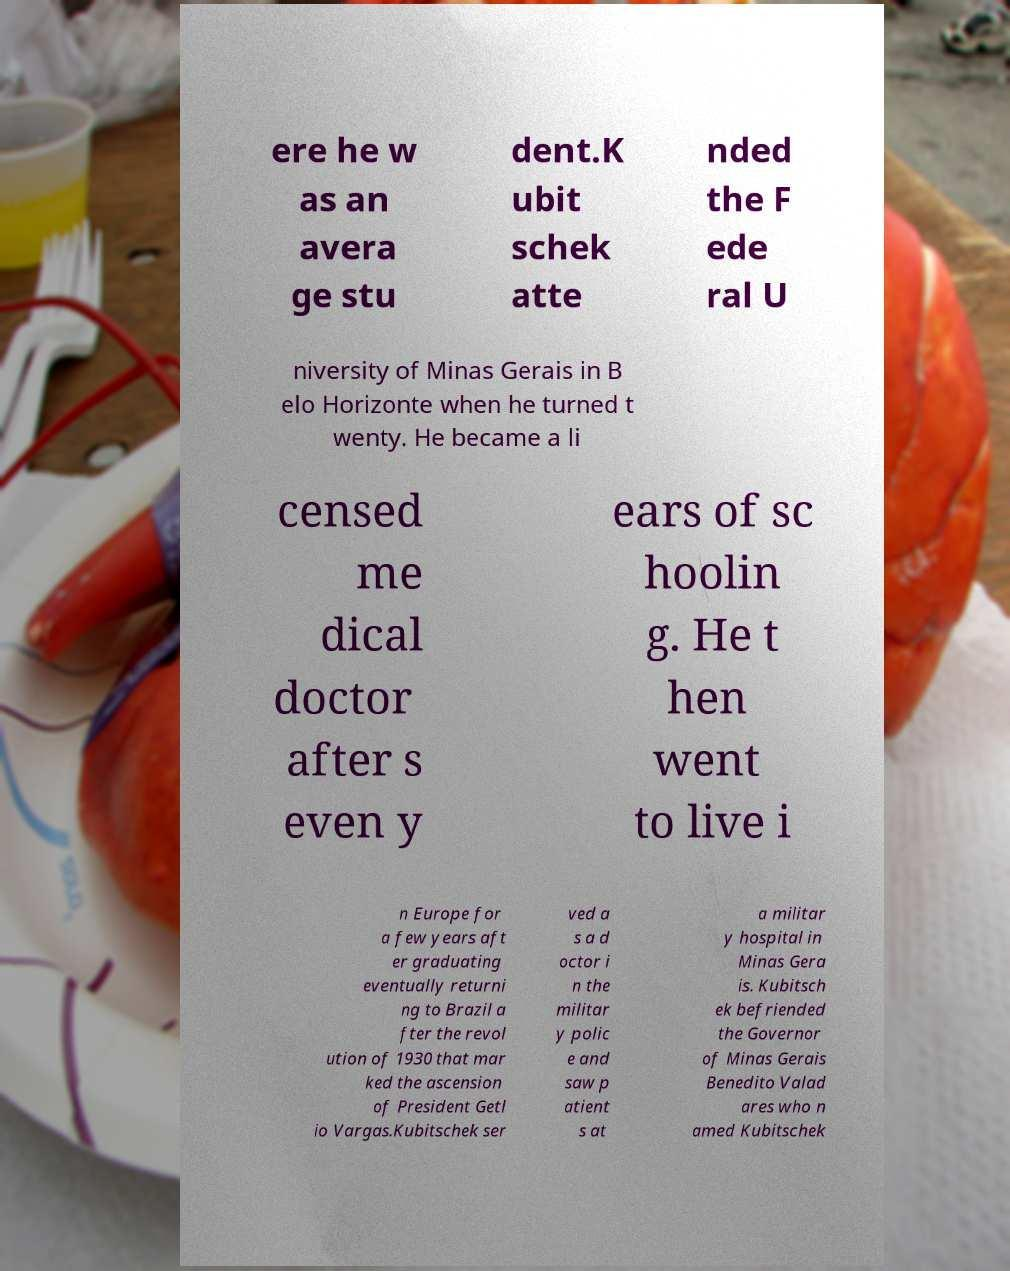Could you extract and type out the text from this image? ere he w as an avera ge stu dent.K ubit schek atte nded the F ede ral U niversity of Minas Gerais in B elo Horizonte when he turned t wenty. He became a li censed me dical doctor after s even y ears of sc hoolin g. He t hen went to live i n Europe for a few years aft er graduating eventually returni ng to Brazil a fter the revol ution of 1930 that mar ked the ascension of President Getl io Vargas.Kubitschek ser ved a s a d octor i n the militar y polic e and saw p atient s at a militar y hospital in Minas Gera is. Kubitsch ek befriended the Governor of Minas Gerais Benedito Valad ares who n amed Kubitschek 